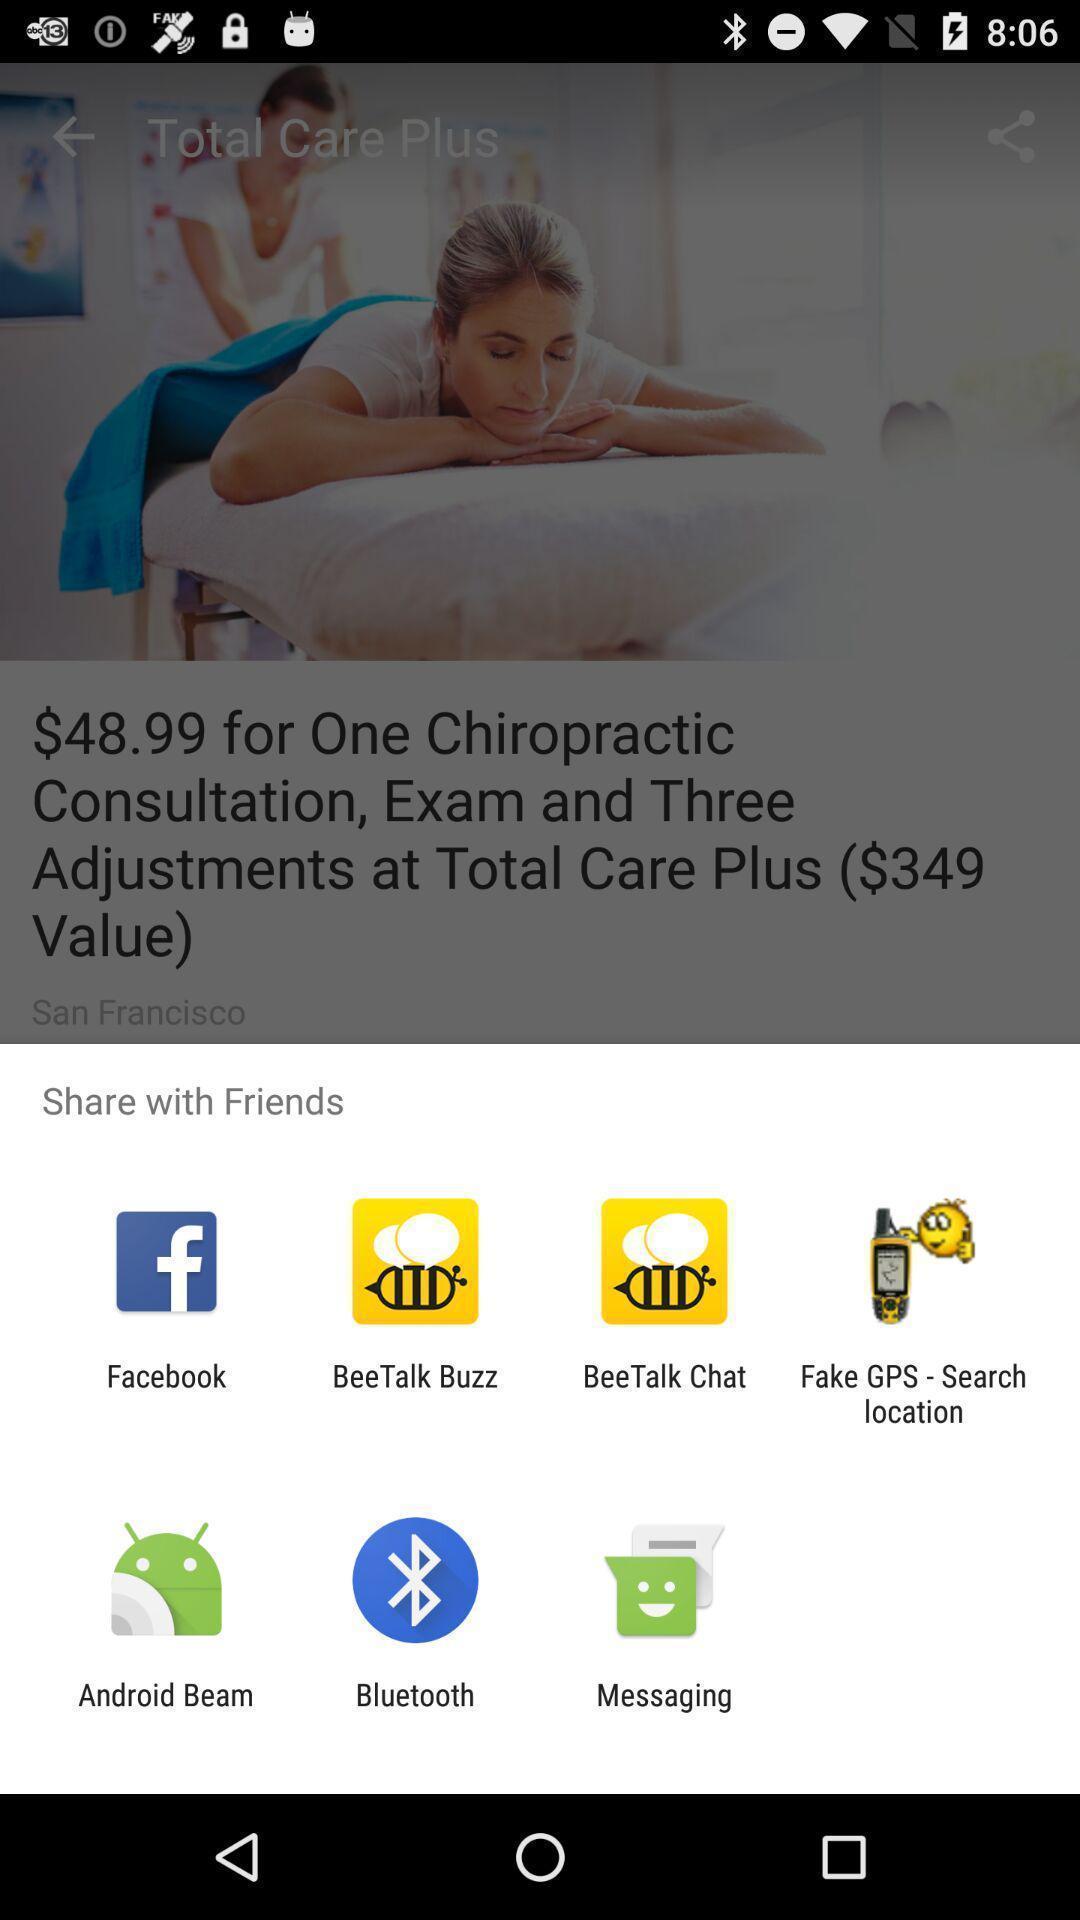Summarize the information in this screenshot. Pop-up showing multiple options to share. 